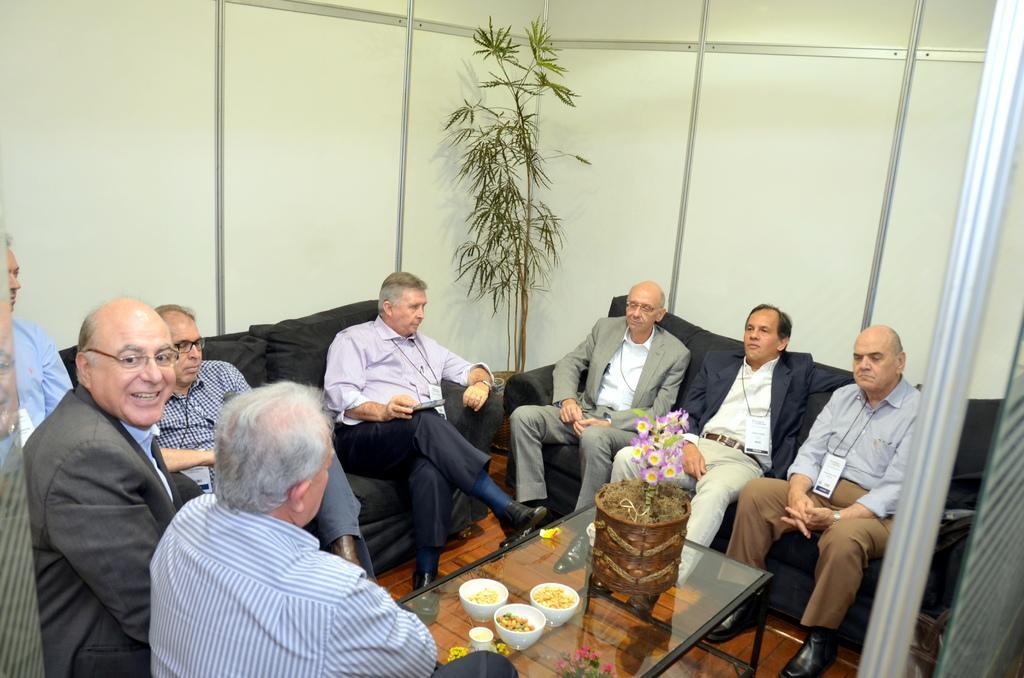Please provide a concise description of this image. In this picture, there are group of men sitting on the sofas. In the center, there is a table. On the table, there are three bowls of food and a flower vase. Towards the right, there are two men wearing blazers and other man is wearing a shirt. On the top, there is a plant. In the background there is a cardboard. 